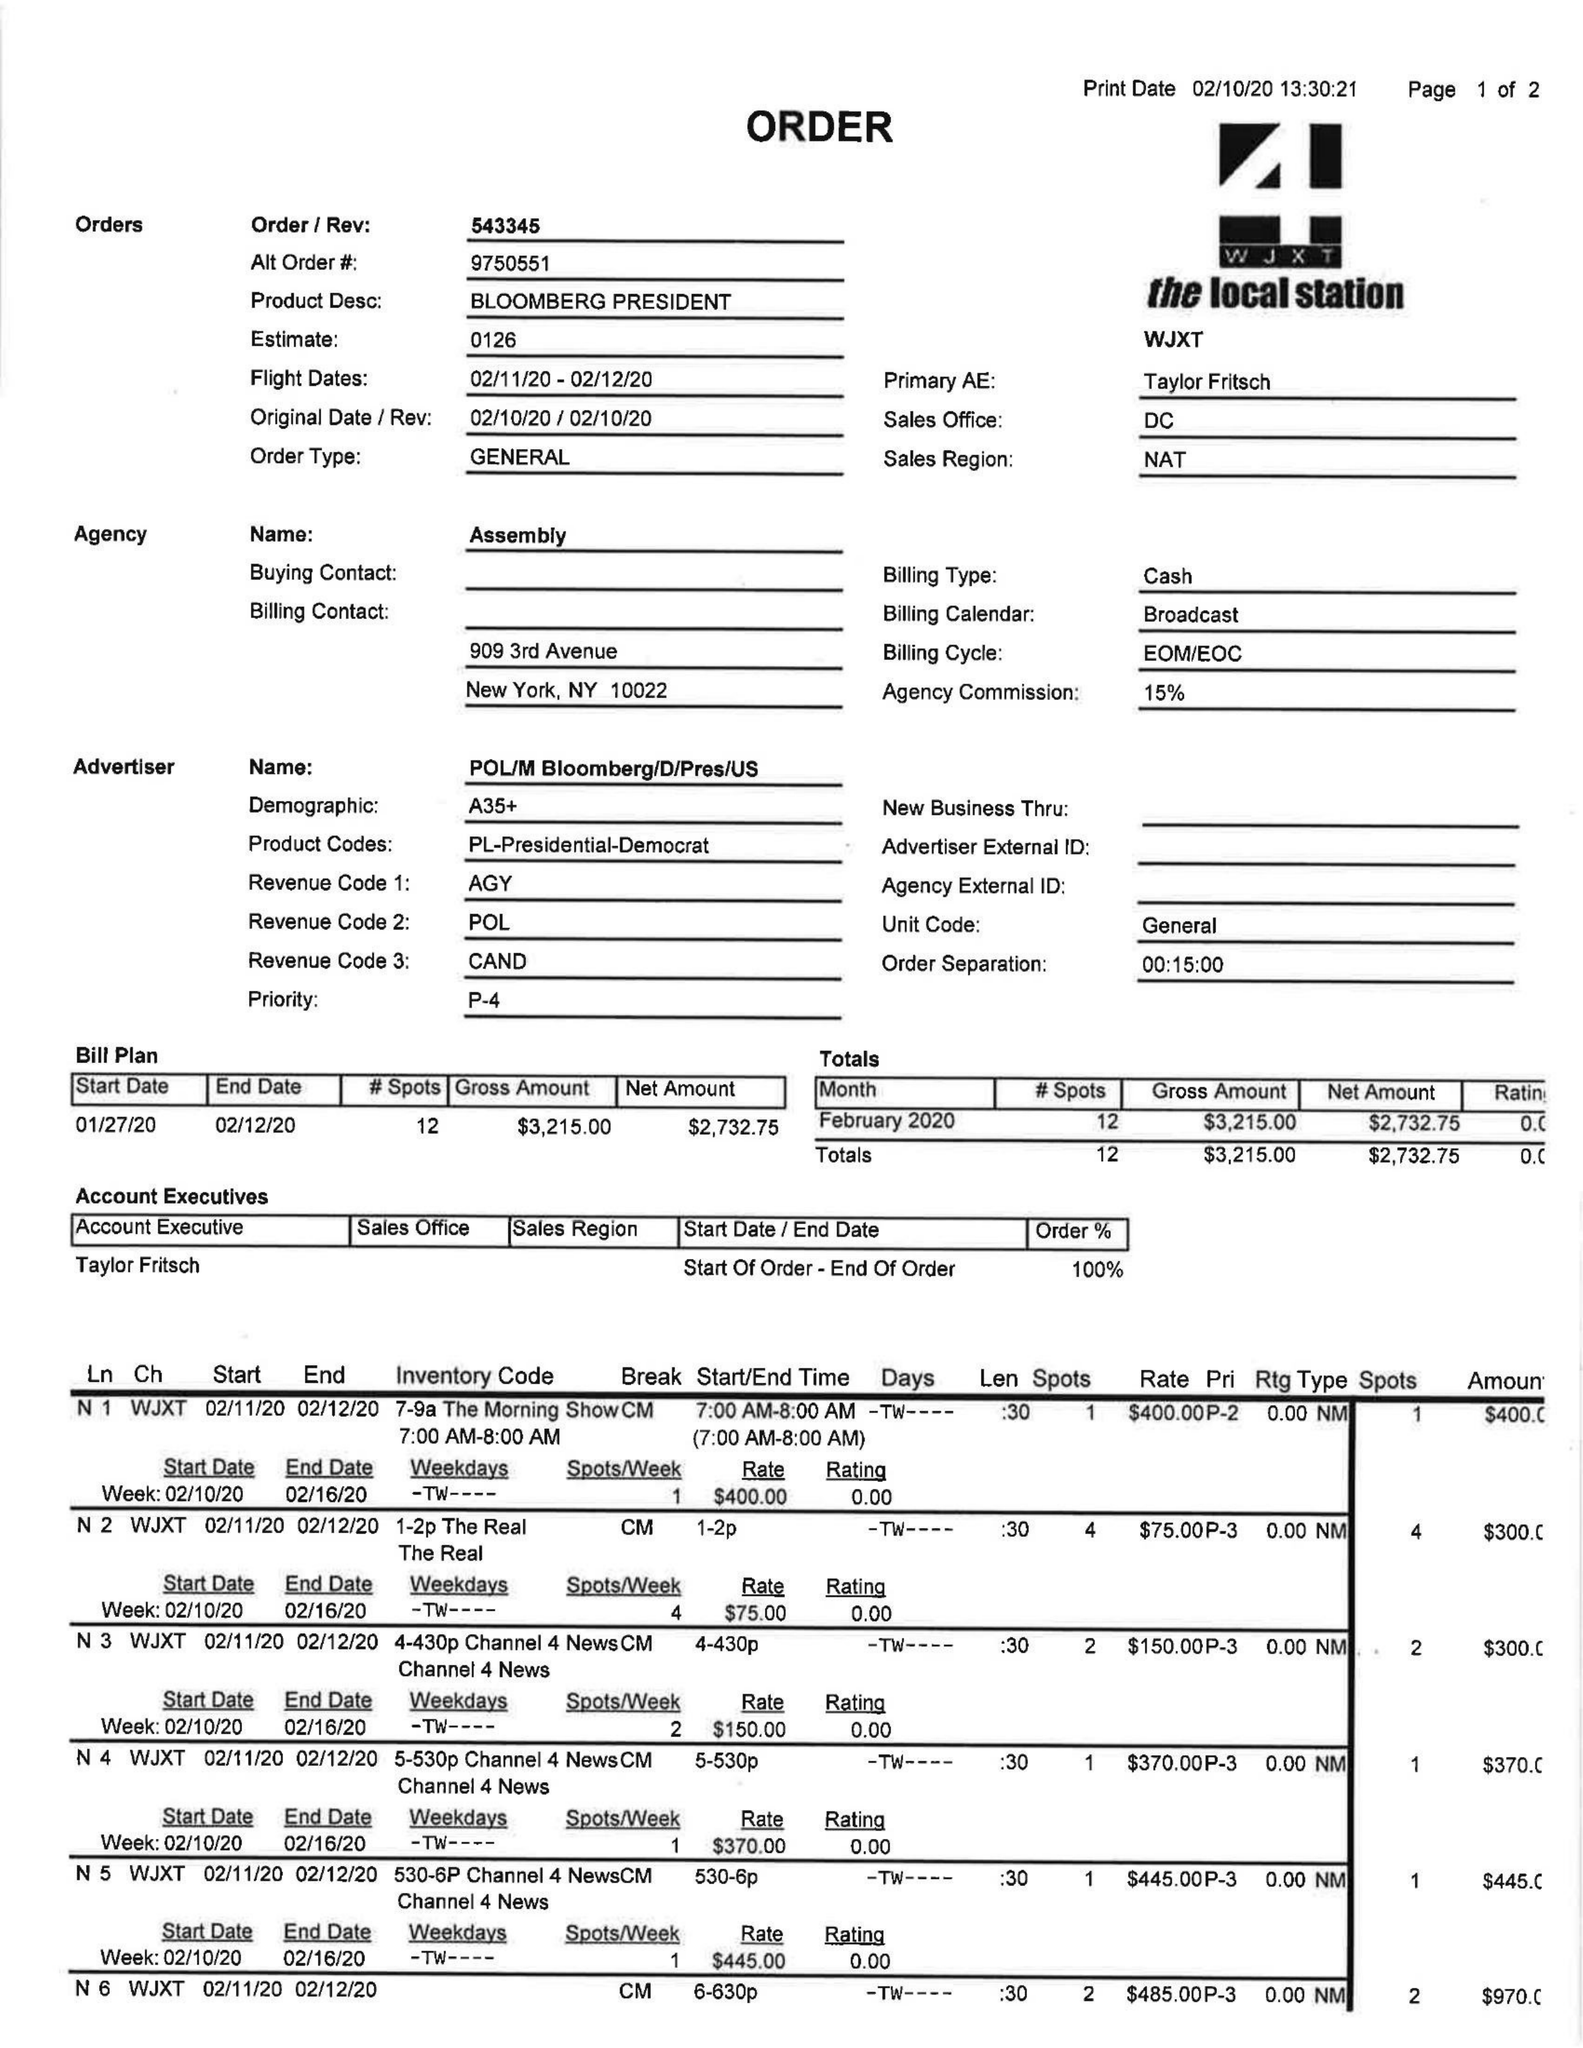What is the value for the contract_num?
Answer the question using a single word or phrase. 543345 